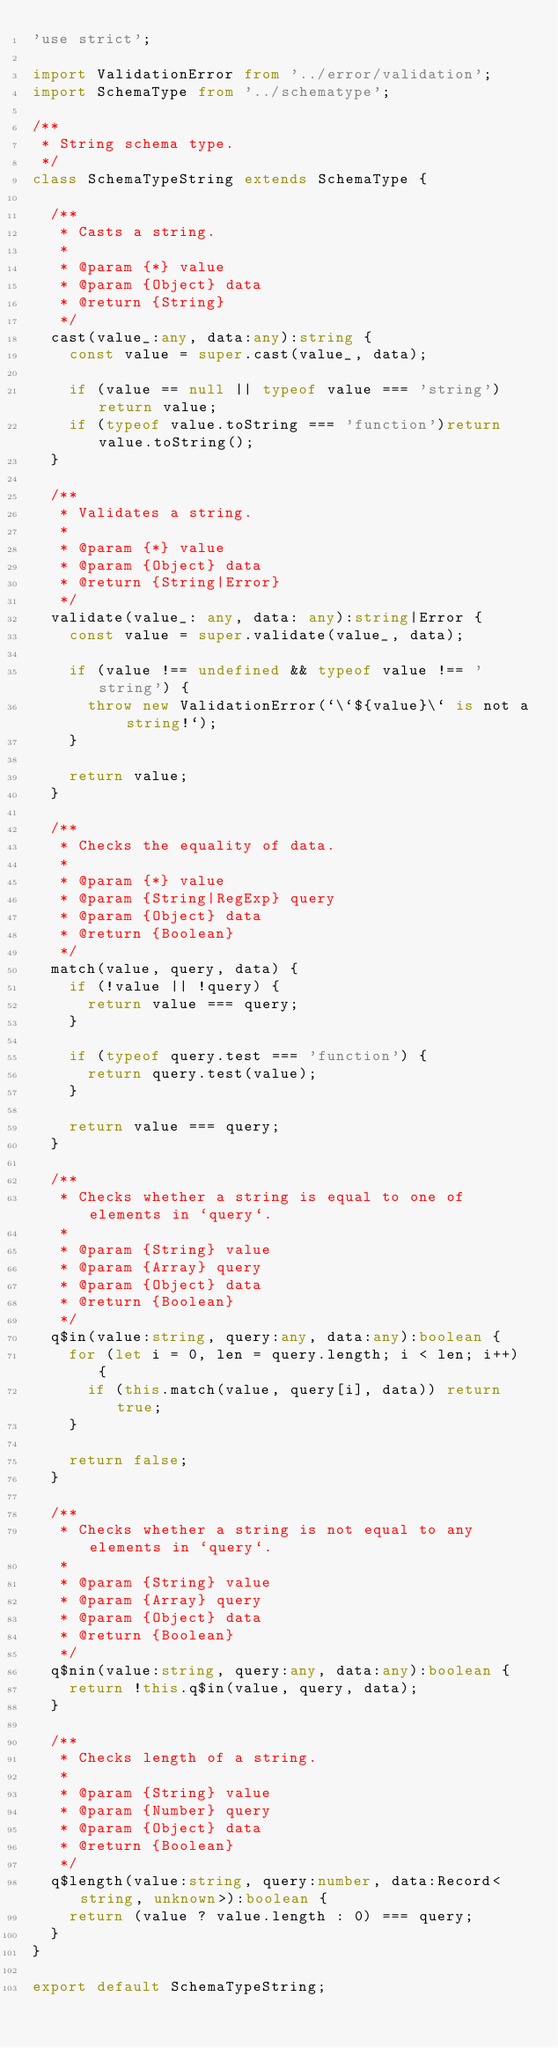<code> <loc_0><loc_0><loc_500><loc_500><_TypeScript_>'use strict';

import ValidationError from '../error/validation';
import SchemaType from '../schematype';

/**
 * String schema type.
 */
class SchemaTypeString extends SchemaType {

  /**
   * Casts a string.
   *
   * @param {*} value
   * @param {Object} data
   * @return {String}
   */
  cast(value_:any, data:any):string {
    const value = super.cast(value_, data);

    if (value == null || typeof value === 'string') return value;
    if (typeof value.toString === 'function')return value.toString();
  }

  /**
   * Validates a string.
   *
   * @param {*} value
   * @param {Object} data
   * @return {String|Error}
   */
  validate(value_: any, data: any):string|Error {
    const value = super.validate(value_, data);

    if (value !== undefined && typeof value !== 'string') {
      throw new ValidationError(`\`${value}\` is not a string!`);
    }

    return value;
  }

  /**
   * Checks the equality of data.
   *
   * @param {*} value
   * @param {String|RegExp} query
   * @param {Object} data
   * @return {Boolean}
   */
  match(value, query, data) {
    if (!value || !query) {
      return value === query;
    }

    if (typeof query.test === 'function') {
      return query.test(value);
    }

    return value === query;
  }

  /**
   * Checks whether a string is equal to one of elements in `query`.
   *
   * @param {String} value
   * @param {Array} query
   * @param {Object} data
   * @return {Boolean}
   */
  q$in(value:string, query:any, data:any):boolean {
    for (let i = 0, len = query.length; i < len; i++) {
      if (this.match(value, query[i], data)) return true;
    }

    return false;
  }

  /**
   * Checks whether a string is not equal to any elements in `query`.
   *
   * @param {String} value
   * @param {Array} query
   * @param {Object} data
   * @return {Boolean}
   */
  q$nin(value:string, query:any, data:any):boolean {
    return !this.q$in(value, query, data);
  }

  /**
   * Checks length of a string.
   *
   * @param {String} value
   * @param {Number} query
   * @param {Object} data
   * @return {Boolean}
   */
  q$length(value:string, query:number, data:Record<string, unknown>):boolean {
    return (value ? value.length : 0) === query;
  }
}

export default SchemaTypeString;
</code> 